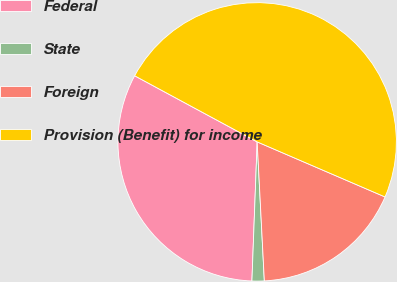<chart> <loc_0><loc_0><loc_500><loc_500><pie_chart><fcel>Federal<fcel>State<fcel>Foreign<fcel>Provision (Benefit) for income<nl><fcel>32.28%<fcel>1.42%<fcel>17.71%<fcel>48.6%<nl></chart> 